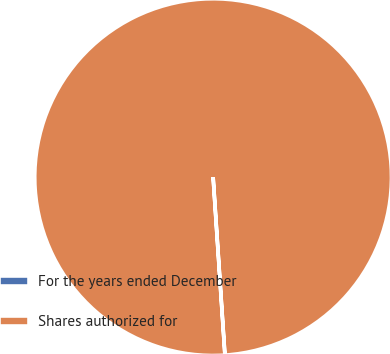<chart> <loc_0><loc_0><loc_500><loc_500><pie_chart><fcel>For the years ended December<fcel>Shares authorized for<nl><fcel>0.0%<fcel>100.0%<nl></chart> 